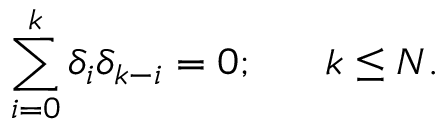<formula> <loc_0><loc_0><loc_500><loc_500>\sum _ { i = 0 } ^ { k } \delta _ { i } \delta _ { k - i } = 0 ; \quad \ k \leq N .</formula> 